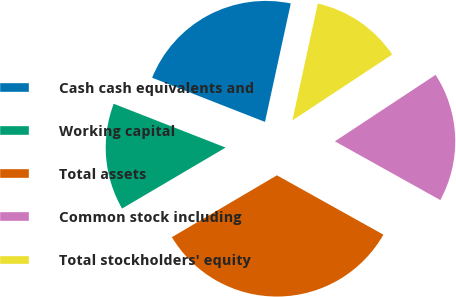<chart> <loc_0><loc_0><loc_500><loc_500><pie_chart><fcel>Cash cash equivalents and<fcel>Working capital<fcel>Total assets<fcel>Common stock including<fcel>Total stockholders' equity<nl><fcel>22.47%<fcel>14.41%<fcel>33.43%<fcel>17.38%<fcel>12.3%<nl></chart> 